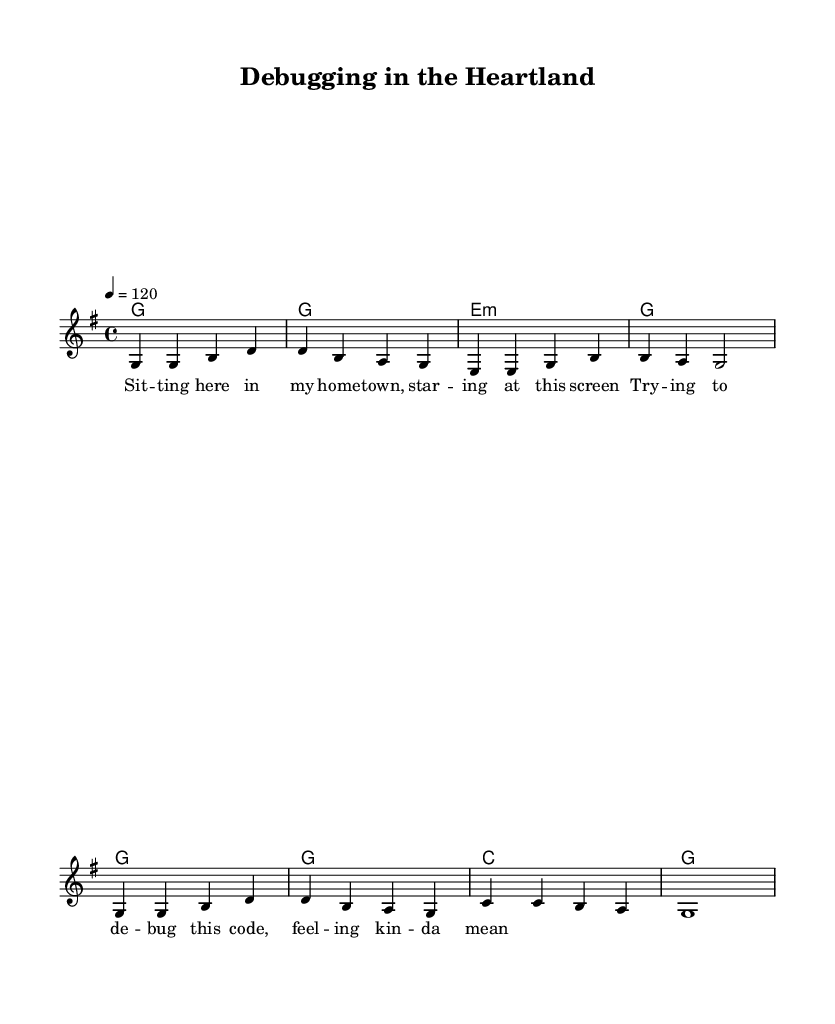What is the key signature of this music? The key signature is G major, which has one sharp (F#). It is indicated at the beginning of the staff.
Answer: G major What is the time signature of this piece? The time signature is 4/4, which means there are four beats in each measure and the quarter note gets one beat. This is typically indicated at the start of the score.
Answer: 4/4 What is the tempo marking for this composition? The tempo marking is 120 beats per minute, indicated by the tempo statement "4 = 120". It provides a guideline for the speed at which the piece should be played.
Answer: 120 How many measures are in the melody? The melody consists of eight measures in total, as counted from the beginning of the musical notation to the end of the given melody section.
Answer: 8 What type of chords are primarily used in this piece? The piece primarily uses major and minor triads, which are common in country rock music. These chords provide a harmonic structure that complements the melody.
Answer: Major and minor triads What is the theme of the lyrics in this song? The theme of the lyrics revolves around coding and debugging, which reflects a modern tech life experience. This relates to the song's country rock style, blending traditional themes with contemporary topics.
Answer: Coding and debugging 